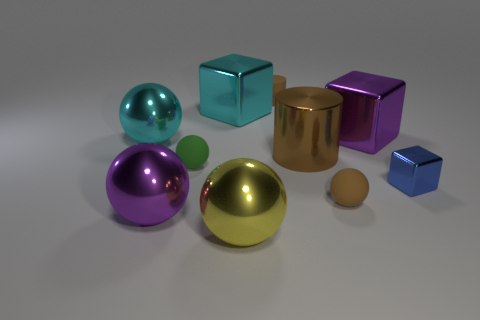What number of other objects are there of the same color as the rubber cylinder?
Your response must be concise. 2. There is a blue cube; are there any large metal things on the right side of it?
Give a very brief answer. No. There is a big thing that is to the left of the purple thing on the left side of the tiny sphere to the left of the large yellow sphere; what is its color?
Your answer should be compact. Cyan. How many matte balls are both to the left of the big brown metallic cylinder and in front of the green thing?
Your answer should be compact. 0. How many balls are small brown rubber objects or matte things?
Make the answer very short. 2. Is there a large matte ball?
Offer a very short reply. No. What number of other objects are there of the same material as the small blue cube?
Ensure brevity in your answer.  6. What is the material of the purple block that is the same size as the yellow thing?
Give a very brief answer. Metal. There is a yellow shiny object to the left of the brown matte cylinder; is it the same shape as the green rubber thing?
Offer a terse response. Yes. Does the matte cylinder have the same color as the large metallic cylinder?
Provide a short and direct response. Yes. 